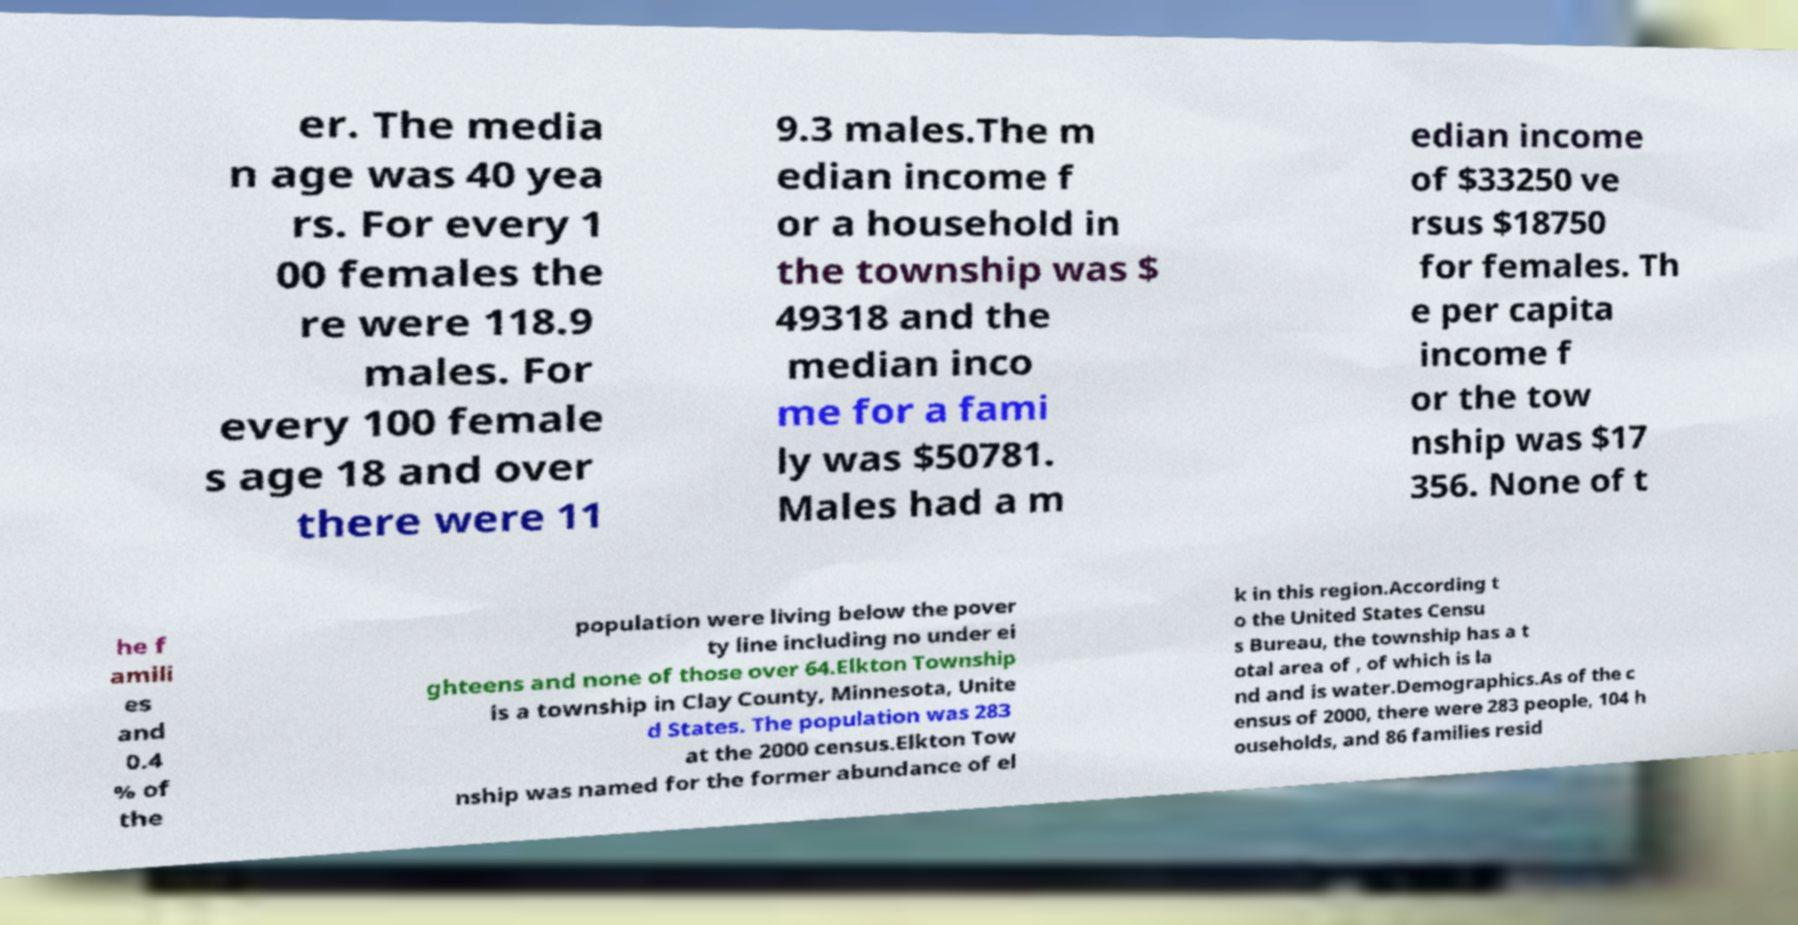Could you extract and type out the text from this image? er. The media n age was 40 yea rs. For every 1 00 females the re were 118.9 males. For every 100 female s age 18 and over there were 11 9.3 males.The m edian income f or a household in the township was $ 49318 and the median inco me for a fami ly was $50781. Males had a m edian income of $33250 ve rsus $18750 for females. Th e per capita income f or the tow nship was $17 356. None of t he f amili es and 0.4 % of the population were living below the pover ty line including no under ei ghteens and none of those over 64.Elkton Township is a township in Clay County, Minnesota, Unite d States. The population was 283 at the 2000 census.Elkton Tow nship was named for the former abundance of el k in this region.According t o the United States Censu s Bureau, the township has a t otal area of , of which is la nd and is water.Demographics.As of the c ensus of 2000, there were 283 people, 104 h ouseholds, and 86 families resid 